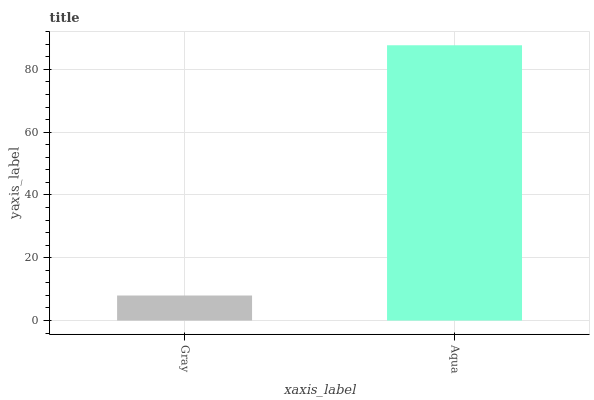Is Gray the minimum?
Answer yes or no. Yes. Is Aqua the maximum?
Answer yes or no. Yes. Is Aqua the minimum?
Answer yes or no. No. Is Aqua greater than Gray?
Answer yes or no. Yes. Is Gray less than Aqua?
Answer yes or no. Yes. Is Gray greater than Aqua?
Answer yes or no. No. Is Aqua less than Gray?
Answer yes or no. No. Is Aqua the high median?
Answer yes or no. Yes. Is Gray the low median?
Answer yes or no. Yes. Is Gray the high median?
Answer yes or no. No. Is Aqua the low median?
Answer yes or no. No. 